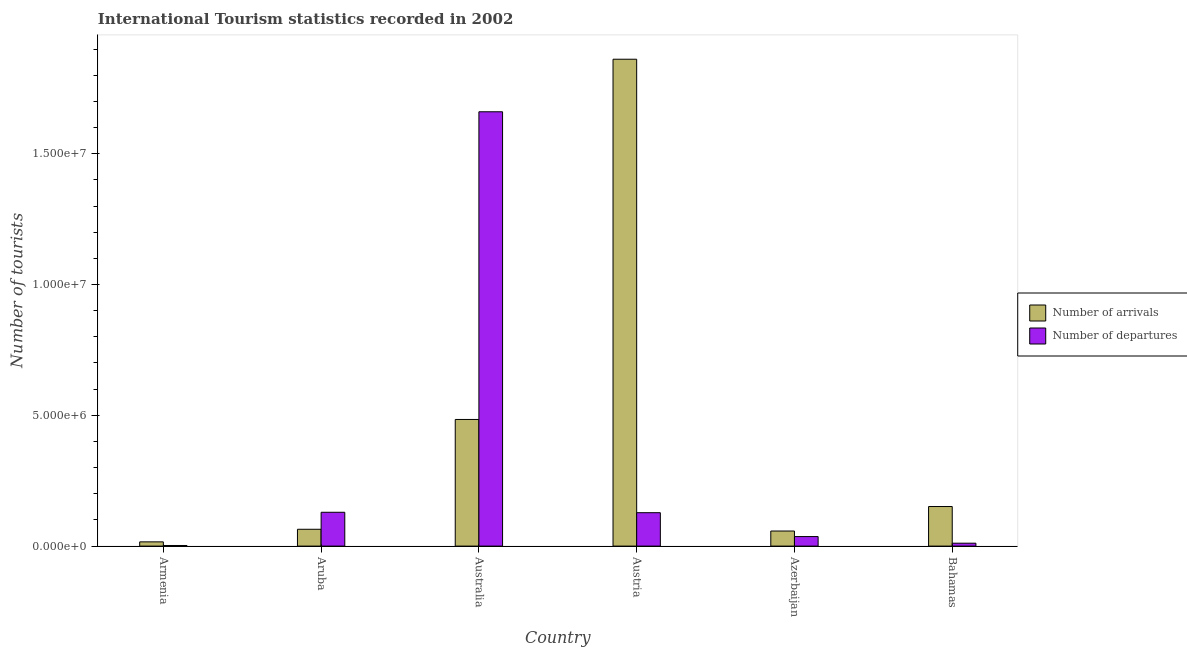Are the number of bars on each tick of the X-axis equal?
Ensure brevity in your answer.  Yes. How many bars are there on the 5th tick from the right?
Keep it short and to the point. 2. What is the label of the 5th group of bars from the left?
Make the answer very short. Azerbaijan. In how many cases, is the number of bars for a given country not equal to the number of legend labels?
Keep it short and to the point. 0. What is the number of tourist departures in Australia?
Keep it short and to the point. 1.66e+07. Across all countries, what is the maximum number of tourist departures?
Your response must be concise. 1.66e+07. Across all countries, what is the minimum number of tourist departures?
Your response must be concise. 2.30e+04. In which country was the number of tourist departures minimum?
Ensure brevity in your answer.  Armenia. What is the total number of tourist departures in the graph?
Give a very brief answer. 1.97e+07. What is the difference between the number of tourist arrivals in Aruba and that in Austria?
Keep it short and to the point. -1.80e+07. What is the difference between the number of tourist arrivals in Azerbaijan and the number of tourist departures in Armenia?
Give a very brief answer. 5.53e+05. What is the average number of tourist departures per country?
Provide a short and direct response. 3.28e+06. What is the difference between the number of tourist departures and number of tourist arrivals in Bahamas?
Ensure brevity in your answer.  -1.40e+06. In how many countries, is the number of tourist arrivals greater than 14000000 ?
Make the answer very short. 1. What is the ratio of the number of tourist departures in Aruba to that in Azerbaijan?
Your response must be concise. 3.55. Is the number of tourist departures in Australia less than that in Azerbaijan?
Make the answer very short. No. Is the difference between the number of tourist departures in Armenia and Aruba greater than the difference between the number of tourist arrivals in Armenia and Aruba?
Ensure brevity in your answer.  No. What is the difference between the highest and the second highest number of tourist arrivals?
Provide a succinct answer. 1.38e+07. What is the difference between the highest and the lowest number of tourist arrivals?
Offer a terse response. 1.84e+07. In how many countries, is the number of tourist arrivals greater than the average number of tourist arrivals taken over all countries?
Provide a succinct answer. 2. Is the sum of the number of tourist departures in Armenia and Austria greater than the maximum number of tourist arrivals across all countries?
Make the answer very short. No. What does the 1st bar from the left in Azerbaijan represents?
Offer a very short reply. Number of arrivals. What does the 1st bar from the right in Austria represents?
Keep it short and to the point. Number of departures. Are all the bars in the graph horizontal?
Offer a terse response. No. How many countries are there in the graph?
Provide a short and direct response. 6. What is the difference between two consecutive major ticks on the Y-axis?
Your answer should be very brief. 5.00e+06. Are the values on the major ticks of Y-axis written in scientific E-notation?
Give a very brief answer. Yes. How many legend labels are there?
Keep it short and to the point. 2. What is the title of the graph?
Your answer should be compact. International Tourism statistics recorded in 2002. What is the label or title of the X-axis?
Offer a terse response. Country. What is the label or title of the Y-axis?
Ensure brevity in your answer.  Number of tourists. What is the Number of tourists of Number of arrivals in Armenia?
Make the answer very short. 1.62e+05. What is the Number of tourists of Number of departures in Armenia?
Your response must be concise. 2.30e+04. What is the Number of tourists in Number of arrivals in Aruba?
Make the answer very short. 6.43e+05. What is the Number of tourists of Number of departures in Aruba?
Provide a succinct answer. 1.29e+06. What is the Number of tourists of Number of arrivals in Australia?
Make the answer very short. 4.84e+06. What is the Number of tourists in Number of departures in Australia?
Your response must be concise. 1.66e+07. What is the Number of tourists of Number of arrivals in Austria?
Make the answer very short. 1.86e+07. What is the Number of tourists of Number of departures in Austria?
Offer a very short reply. 1.28e+06. What is the Number of tourists in Number of arrivals in Azerbaijan?
Give a very brief answer. 5.76e+05. What is the Number of tourists in Number of departures in Azerbaijan?
Ensure brevity in your answer.  3.64e+05. What is the Number of tourists of Number of arrivals in Bahamas?
Provide a short and direct response. 1.51e+06. What is the Number of tourists of Number of departures in Bahamas?
Keep it short and to the point. 1.11e+05. Across all countries, what is the maximum Number of tourists of Number of arrivals?
Make the answer very short. 1.86e+07. Across all countries, what is the maximum Number of tourists in Number of departures?
Give a very brief answer. 1.66e+07. Across all countries, what is the minimum Number of tourists in Number of arrivals?
Keep it short and to the point. 1.62e+05. Across all countries, what is the minimum Number of tourists in Number of departures?
Keep it short and to the point. 2.30e+04. What is the total Number of tourists in Number of arrivals in the graph?
Offer a terse response. 2.63e+07. What is the total Number of tourists of Number of departures in the graph?
Offer a very short reply. 1.97e+07. What is the difference between the Number of tourists in Number of arrivals in Armenia and that in Aruba?
Your response must be concise. -4.81e+05. What is the difference between the Number of tourists in Number of departures in Armenia and that in Aruba?
Provide a succinct answer. -1.27e+06. What is the difference between the Number of tourists in Number of arrivals in Armenia and that in Australia?
Offer a very short reply. -4.68e+06. What is the difference between the Number of tourists in Number of departures in Armenia and that in Australia?
Your answer should be compact. -1.66e+07. What is the difference between the Number of tourists in Number of arrivals in Armenia and that in Austria?
Provide a short and direct response. -1.84e+07. What is the difference between the Number of tourists of Number of departures in Armenia and that in Austria?
Offer a terse response. -1.25e+06. What is the difference between the Number of tourists of Number of arrivals in Armenia and that in Azerbaijan?
Provide a short and direct response. -4.14e+05. What is the difference between the Number of tourists of Number of departures in Armenia and that in Azerbaijan?
Ensure brevity in your answer.  -3.41e+05. What is the difference between the Number of tourists in Number of arrivals in Armenia and that in Bahamas?
Your response must be concise. -1.35e+06. What is the difference between the Number of tourists in Number of departures in Armenia and that in Bahamas?
Make the answer very short. -8.80e+04. What is the difference between the Number of tourists in Number of arrivals in Aruba and that in Australia?
Give a very brief answer. -4.20e+06. What is the difference between the Number of tourists in Number of departures in Aruba and that in Australia?
Your answer should be compact. -1.53e+07. What is the difference between the Number of tourists of Number of arrivals in Aruba and that in Austria?
Your response must be concise. -1.80e+07. What is the difference between the Number of tourists in Number of departures in Aruba and that in Austria?
Ensure brevity in your answer.  1.60e+04. What is the difference between the Number of tourists of Number of arrivals in Aruba and that in Azerbaijan?
Your answer should be very brief. 6.70e+04. What is the difference between the Number of tourists in Number of departures in Aruba and that in Azerbaijan?
Your answer should be compact. 9.29e+05. What is the difference between the Number of tourists in Number of arrivals in Aruba and that in Bahamas?
Your response must be concise. -8.70e+05. What is the difference between the Number of tourists in Number of departures in Aruba and that in Bahamas?
Offer a terse response. 1.18e+06. What is the difference between the Number of tourists in Number of arrivals in Australia and that in Austria?
Give a very brief answer. -1.38e+07. What is the difference between the Number of tourists in Number of departures in Australia and that in Austria?
Keep it short and to the point. 1.53e+07. What is the difference between the Number of tourists of Number of arrivals in Australia and that in Azerbaijan?
Your answer should be very brief. 4.26e+06. What is the difference between the Number of tourists in Number of departures in Australia and that in Azerbaijan?
Give a very brief answer. 1.62e+07. What is the difference between the Number of tourists of Number of arrivals in Australia and that in Bahamas?
Your answer should be compact. 3.33e+06. What is the difference between the Number of tourists of Number of departures in Australia and that in Bahamas?
Your response must be concise. 1.65e+07. What is the difference between the Number of tourists of Number of arrivals in Austria and that in Azerbaijan?
Offer a terse response. 1.80e+07. What is the difference between the Number of tourists of Number of departures in Austria and that in Azerbaijan?
Give a very brief answer. 9.13e+05. What is the difference between the Number of tourists of Number of arrivals in Austria and that in Bahamas?
Make the answer very short. 1.71e+07. What is the difference between the Number of tourists of Number of departures in Austria and that in Bahamas?
Provide a short and direct response. 1.17e+06. What is the difference between the Number of tourists in Number of arrivals in Azerbaijan and that in Bahamas?
Give a very brief answer. -9.37e+05. What is the difference between the Number of tourists in Number of departures in Azerbaijan and that in Bahamas?
Provide a short and direct response. 2.53e+05. What is the difference between the Number of tourists in Number of arrivals in Armenia and the Number of tourists in Number of departures in Aruba?
Your answer should be compact. -1.13e+06. What is the difference between the Number of tourists in Number of arrivals in Armenia and the Number of tourists in Number of departures in Australia?
Provide a succinct answer. -1.64e+07. What is the difference between the Number of tourists of Number of arrivals in Armenia and the Number of tourists of Number of departures in Austria?
Make the answer very short. -1.12e+06. What is the difference between the Number of tourists of Number of arrivals in Armenia and the Number of tourists of Number of departures in Azerbaijan?
Your answer should be compact. -2.02e+05. What is the difference between the Number of tourists in Number of arrivals in Armenia and the Number of tourists in Number of departures in Bahamas?
Give a very brief answer. 5.10e+04. What is the difference between the Number of tourists of Number of arrivals in Aruba and the Number of tourists of Number of departures in Australia?
Ensure brevity in your answer.  -1.60e+07. What is the difference between the Number of tourists in Number of arrivals in Aruba and the Number of tourists in Number of departures in Austria?
Your response must be concise. -6.34e+05. What is the difference between the Number of tourists in Number of arrivals in Aruba and the Number of tourists in Number of departures in Azerbaijan?
Offer a terse response. 2.79e+05. What is the difference between the Number of tourists of Number of arrivals in Aruba and the Number of tourists of Number of departures in Bahamas?
Offer a terse response. 5.32e+05. What is the difference between the Number of tourists of Number of arrivals in Australia and the Number of tourists of Number of departures in Austria?
Provide a short and direct response. 3.56e+06. What is the difference between the Number of tourists in Number of arrivals in Australia and the Number of tourists in Number of departures in Azerbaijan?
Keep it short and to the point. 4.48e+06. What is the difference between the Number of tourists of Number of arrivals in Australia and the Number of tourists of Number of departures in Bahamas?
Your answer should be very brief. 4.73e+06. What is the difference between the Number of tourists in Number of arrivals in Austria and the Number of tourists in Number of departures in Azerbaijan?
Provide a short and direct response. 1.82e+07. What is the difference between the Number of tourists of Number of arrivals in Austria and the Number of tourists of Number of departures in Bahamas?
Your answer should be compact. 1.85e+07. What is the difference between the Number of tourists in Number of arrivals in Azerbaijan and the Number of tourists in Number of departures in Bahamas?
Offer a terse response. 4.65e+05. What is the average Number of tourists of Number of arrivals per country?
Your response must be concise. 4.39e+06. What is the average Number of tourists of Number of departures per country?
Provide a succinct answer. 3.28e+06. What is the difference between the Number of tourists in Number of arrivals and Number of tourists in Number of departures in Armenia?
Give a very brief answer. 1.39e+05. What is the difference between the Number of tourists of Number of arrivals and Number of tourists of Number of departures in Aruba?
Provide a short and direct response. -6.50e+05. What is the difference between the Number of tourists in Number of arrivals and Number of tourists in Number of departures in Australia?
Your answer should be very brief. -1.18e+07. What is the difference between the Number of tourists in Number of arrivals and Number of tourists in Number of departures in Austria?
Provide a succinct answer. 1.73e+07. What is the difference between the Number of tourists in Number of arrivals and Number of tourists in Number of departures in Azerbaijan?
Your answer should be very brief. 2.12e+05. What is the difference between the Number of tourists in Number of arrivals and Number of tourists in Number of departures in Bahamas?
Your response must be concise. 1.40e+06. What is the ratio of the Number of tourists in Number of arrivals in Armenia to that in Aruba?
Make the answer very short. 0.25. What is the ratio of the Number of tourists in Number of departures in Armenia to that in Aruba?
Your answer should be very brief. 0.02. What is the ratio of the Number of tourists in Number of arrivals in Armenia to that in Australia?
Your answer should be very brief. 0.03. What is the ratio of the Number of tourists in Number of departures in Armenia to that in Australia?
Keep it short and to the point. 0. What is the ratio of the Number of tourists of Number of arrivals in Armenia to that in Austria?
Your response must be concise. 0.01. What is the ratio of the Number of tourists in Number of departures in Armenia to that in Austria?
Ensure brevity in your answer.  0.02. What is the ratio of the Number of tourists of Number of arrivals in Armenia to that in Azerbaijan?
Give a very brief answer. 0.28. What is the ratio of the Number of tourists in Number of departures in Armenia to that in Azerbaijan?
Your answer should be very brief. 0.06. What is the ratio of the Number of tourists of Number of arrivals in Armenia to that in Bahamas?
Make the answer very short. 0.11. What is the ratio of the Number of tourists of Number of departures in Armenia to that in Bahamas?
Your answer should be very brief. 0.21. What is the ratio of the Number of tourists in Number of arrivals in Aruba to that in Australia?
Ensure brevity in your answer.  0.13. What is the ratio of the Number of tourists of Number of departures in Aruba to that in Australia?
Make the answer very short. 0.08. What is the ratio of the Number of tourists in Number of arrivals in Aruba to that in Austria?
Your answer should be compact. 0.03. What is the ratio of the Number of tourists in Number of departures in Aruba to that in Austria?
Your response must be concise. 1.01. What is the ratio of the Number of tourists of Number of arrivals in Aruba to that in Azerbaijan?
Keep it short and to the point. 1.12. What is the ratio of the Number of tourists in Number of departures in Aruba to that in Azerbaijan?
Offer a terse response. 3.55. What is the ratio of the Number of tourists in Number of arrivals in Aruba to that in Bahamas?
Your answer should be very brief. 0.42. What is the ratio of the Number of tourists of Number of departures in Aruba to that in Bahamas?
Give a very brief answer. 11.65. What is the ratio of the Number of tourists in Number of arrivals in Australia to that in Austria?
Ensure brevity in your answer.  0.26. What is the ratio of the Number of tourists in Number of departures in Australia to that in Austria?
Your answer should be very brief. 13. What is the ratio of the Number of tourists of Number of arrivals in Australia to that in Azerbaijan?
Provide a short and direct response. 8.4. What is the ratio of the Number of tourists in Number of departures in Australia to that in Azerbaijan?
Keep it short and to the point. 45.61. What is the ratio of the Number of tourists of Number of arrivals in Australia to that in Bahamas?
Provide a short and direct response. 3.2. What is the ratio of the Number of tourists of Number of departures in Australia to that in Bahamas?
Provide a short and direct response. 149.57. What is the ratio of the Number of tourists in Number of arrivals in Austria to that in Azerbaijan?
Your answer should be compact. 32.31. What is the ratio of the Number of tourists in Number of departures in Austria to that in Azerbaijan?
Give a very brief answer. 3.51. What is the ratio of the Number of tourists of Number of arrivals in Austria to that in Bahamas?
Offer a terse response. 12.3. What is the ratio of the Number of tourists in Number of departures in Austria to that in Bahamas?
Make the answer very short. 11.5. What is the ratio of the Number of tourists of Number of arrivals in Azerbaijan to that in Bahamas?
Offer a terse response. 0.38. What is the ratio of the Number of tourists in Number of departures in Azerbaijan to that in Bahamas?
Your answer should be very brief. 3.28. What is the difference between the highest and the second highest Number of tourists of Number of arrivals?
Your answer should be compact. 1.38e+07. What is the difference between the highest and the second highest Number of tourists in Number of departures?
Provide a short and direct response. 1.53e+07. What is the difference between the highest and the lowest Number of tourists of Number of arrivals?
Ensure brevity in your answer.  1.84e+07. What is the difference between the highest and the lowest Number of tourists in Number of departures?
Your answer should be compact. 1.66e+07. 